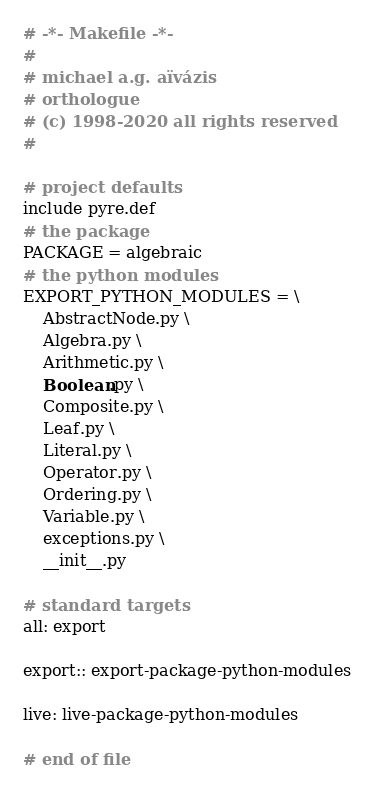<code> <loc_0><loc_0><loc_500><loc_500><_ObjectiveC_># -*- Makefile -*-
#
# michael a.g. aïvázis
# orthologue
# (c) 1998-2020 all rights reserved
#

# project defaults
include pyre.def
# the package
PACKAGE = algebraic
# the python modules
EXPORT_PYTHON_MODULES = \
    AbstractNode.py \
    Algebra.py \
    Arithmetic.py \
    Boolean.py \
    Composite.py \
    Leaf.py \
    Literal.py \
    Operator.py \
    Ordering.py \
    Variable.py \
    exceptions.py \
    __init__.py

# standard targets
all: export

export:: export-package-python-modules

live: live-package-python-modules

# end of file
</code> 